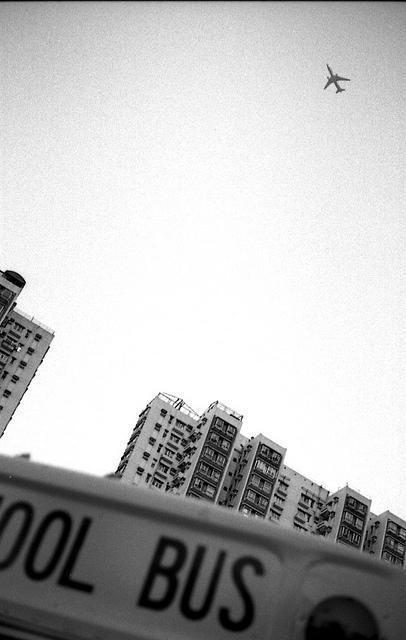How many aircraft are in the sky?
Give a very brief answer. 1. 